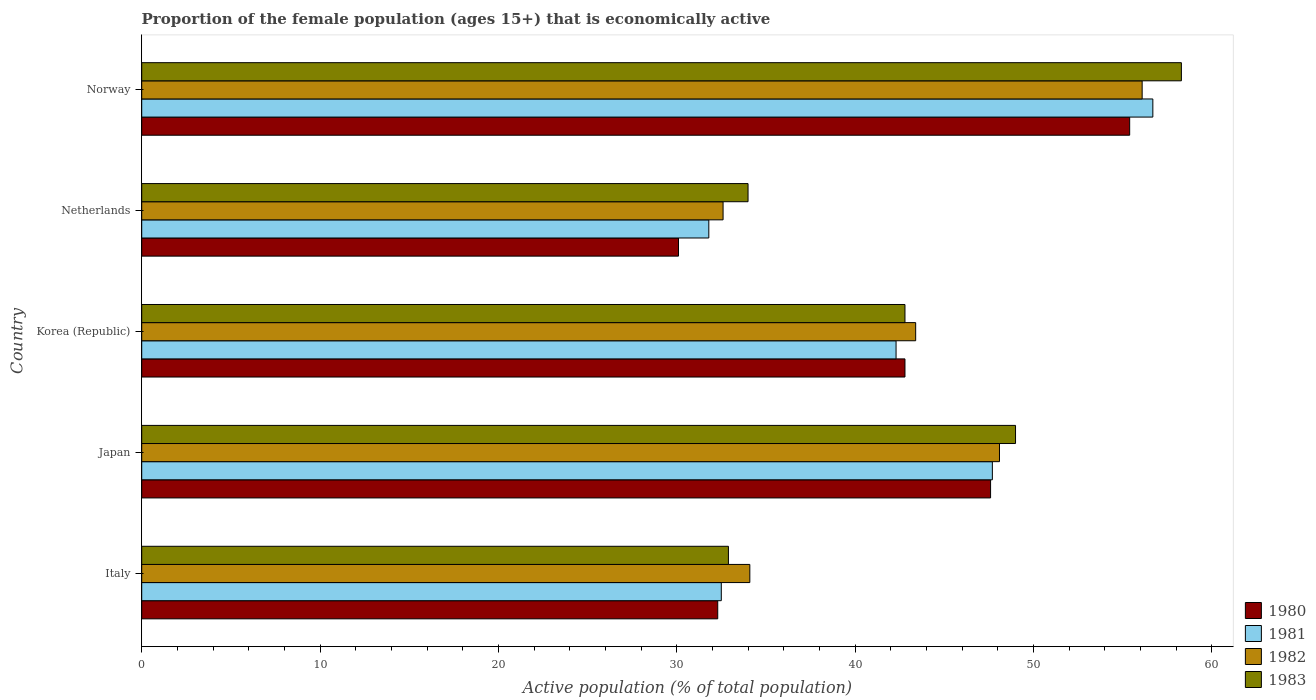How many groups of bars are there?
Offer a terse response. 5. Are the number of bars on each tick of the Y-axis equal?
Offer a terse response. Yes. How many bars are there on the 4th tick from the top?
Provide a short and direct response. 4. How many bars are there on the 5th tick from the bottom?
Your response must be concise. 4. What is the label of the 2nd group of bars from the top?
Give a very brief answer. Netherlands. What is the proportion of the female population that is economically active in 1982 in Norway?
Give a very brief answer. 56.1. Across all countries, what is the maximum proportion of the female population that is economically active in 1982?
Offer a very short reply. 56.1. Across all countries, what is the minimum proportion of the female population that is economically active in 1983?
Keep it short and to the point. 32.9. In which country was the proportion of the female population that is economically active in 1983 maximum?
Offer a very short reply. Norway. What is the total proportion of the female population that is economically active in 1980 in the graph?
Your answer should be compact. 208.2. What is the difference between the proportion of the female population that is economically active in 1983 in Italy and the proportion of the female population that is economically active in 1980 in Norway?
Offer a terse response. -22.5. What is the average proportion of the female population that is economically active in 1982 per country?
Your answer should be very brief. 42.86. What is the difference between the proportion of the female population that is economically active in 1980 and proportion of the female population that is economically active in 1981 in Japan?
Your response must be concise. -0.1. What is the ratio of the proportion of the female population that is economically active in 1983 in Japan to that in Norway?
Provide a short and direct response. 0.84. Is the difference between the proportion of the female population that is economically active in 1980 in Japan and Korea (Republic) greater than the difference between the proportion of the female population that is economically active in 1981 in Japan and Korea (Republic)?
Provide a short and direct response. No. What is the difference between the highest and the lowest proportion of the female population that is economically active in 1980?
Your answer should be very brief. 25.3. In how many countries, is the proportion of the female population that is economically active in 1981 greater than the average proportion of the female population that is economically active in 1981 taken over all countries?
Provide a short and direct response. 3. Is the sum of the proportion of the female population that is economically active in 1983 in Korea (Republic) and Norway greater than the maximum proportion of the female population that is economically active in 1981 across all countries?
Your answer should be very brief. Yes. What does the 1st bar from the bottom in Japan represents?
Ensure brevity in your answer.  1980. Is it the case that in every country, the sum of the proportion of the female population that is economically active in 1983 and proportion of the female population that is economically active in 1980 is greater than the proportion of the female population that is economically active in 1982?
Provide a short and direct response. Yes. Are the values on the major ticks of X-axis written in scientific E-notation?
Offer a very short reply. No. How are the legend labels stacked?
Make the answer very short. Vertical. What is the title of the graph?
Your response must be concise. Proportion of the female population (ages 15+) that is economically active. Does "2006" appear as one of the legend labels in the graph?
Offer a terse response. No. What is the label or title of the X-axis?
Offer a very short reply. Active population (% of total population). What is the label or title of the Y-axis?
Make the answer very short. Country. What is the Active population (% of total population) of 1980 in Italy?
Provide a short and direct response. 32.3. What is the Active population (% of total population) in 1981 in Italy?
Your answer should be very brief. 32.5. What is the Active population (% of total population) of 1982 in Italy?
Your answer should be very brief. 34.1. What is the Active population (% of total population) of 1983 in Italy?
Provide a short and direct response. 32.9. What is the Active population (% of total population) in 1980 in Japan?
Keep it short and to the point. 47.6. What is the Active population (% of total population) in 1981 in Japan?
Your answer should be very brief. 47.7. What is the Active population (% of total population) in 1982 in Japan?
Offer a terse response. 48.1. What is the Active population (% of total population) of 1983 in Japan?
Provide a short and direct response. 49. What is the Active population (% of total population) of 1980 in Korea (Republic)?
Ensure brevity in your answer.  42.8. What is the Active population (% of total population) in 1981 in Korea (Republic)?
Ensure brevity in your answer.  42.3. What is the Active population (% of total population) in 1982 in Korea (Republic)?
Keep it short and to the point. 43.4. What is the Active population (% of total population) in 1983 in Korea (Republic)?
Make the answer very short. 42.8. What is the Active population (% of total population) of 1980 in Netherlands?
Make the answer very short. 30.1. What is the Active population (% of total population) in 1981 in Netherlands?
Keep it short and to the point. 31.8. What is the Active population (% of total population) of 1982 in Netherlands?
Offer a very short reply. 32.6. What is the Active population (% of total population) of 1980 in Norway?
Give a very brief answer. 55.4. What is the Active population (% of total population) in 1981 in Norway?
Your answer should be compact. 56.7. What is the Active population (% of total population) of 1982 in Norway?
Your answer should be compact. 56.1. What is the Active population (% of total population) of 1983 in Norway?
Make the answer very short. 58.3. Across all countries, what is the maximum Active population (% of total population) of 1980?
Offer a very short reply. 55.4. Across all countries, what is the maximum Active population (% of total population) in 1981?
Give a very brief answer. 56.7. Across all countries, what is the maximum Active population (% of total population) in 1982?
Provide a short and direct response. 56.1. Across all countries, what is the maximum Active population (% of total population) in 1983?
Offer a very short reply. 58.3. Across all countries, what is the minimum Active population (% of total population) in 1980?
Keep it short and to the point. 30.1. Across all countries, what is the minimum Active population (% of total population) of 1981?
Keep it short and to the point. 31.8. Across all countries, what is the minimum Active population (% of total population) in 1982?
Make the answer very short. 32.6. Across all countries, what is the minimum Active population (% of total population) of 1983?
Your answer should be very brief. 32.9. What is the total Active population (% of total population) in 1980 in the graph?
Provide a short and direct response. 208.2. What is the total Active population (% of total population) in 1981 in the graph?
Ensure brevity in your answer.  211. What is the total Active population (% of total population) of 1982 in the graph?
Keep it short and to the point. 214.3. What is the total Active population (% of total population) in 1983 in the graph?
Your answer should be compact. 217. What is the difference between the Active population (% of total population) of 1980 in Italy and that in Japan?
Ensure brevity in your answer.  -15.3. What is the difference between the Active population (% of total population) in 1981 in Italy and that in Japan?
Provide a succinct answer. -15.2. What is the difference between the Active population (% of total population) of 1983 in Italy and that in Japan?
Make the answer very short. -16.1. What is the difference between the Active population (% of total population) in 1980 in Italy and that in Korea (Republic)?
Keep it short and to the point. -10.5. What is the difference between the Active population (% of total population) in 1981 in Italy and that in Korea (Republic)?
Offer a terse response. -9.8. What is the difference between the Active population (% of total population) of 1982 in Italy and that in Korea (Republic)?
Your answer should be very brief. -9.3. What is the difference between the Active population (% of total population) in 1983 in Italy and that in Korea (Republic)?
Give a very brief answer. -9.9. What is the difference between the Active population (% of total population) of 1981 in Italy and that in Netherlands?
Offer a very short reply. 0.7. What is the difference between the Active population (% of total population) of 1982 in Italy and that in Netherlands?
Your answer should be very brief. 1.5. What is the difference between the Active population (% of total population) in 1983 in Italy and that in Netherlands?
Give a very brief answer. -1.1. What is the difference between the Active population (% of total population) in 1980 in Italy and that in Norway?
Make the answer very short. -23.1. What is the difference between the Active population (% of total population) of 1981 in Italy and that in Norway?
Offer a very short reply. -24.2. What is the difference between the Active population (% of total population) in 1983 in Italy and that in Norway?
Provide a short and direct response. -25.4. What is the difference between the Active population (% of total population) in 1982 in Japan and that in Korea (Republic)?
Your answer should be very brief. 4.7. What is the difference between the Active population (% of total population) of 1980 in Japan and that in Netherlands?
Ensure brevity in your answer.  17.5. What is the difference between the Active population (% of total population) in 1982 in Japan and that in Netherlands?
Provide a succinct answer. 15.5. What is the difference between the Active population (% of total population) of 1980 in Japan and that in Norway?
Offer a very short reply. -7.8. What is the difference between the Active population (% of total population) of 1981 in Japan and that in Norway?
Make the answer very short. -9. What is the difference between the Active population (% of total population) of 1982 in Japan and that in Norway?
Make the answer very short. -8. What is the difference between the Active population (% of total population) in 1983 in Japan and that in Norway?
Give a very brief answer. -9.3. What is the difference between the Active population (% of total population) in 1982 in Korea (Republic) and that in Netherlands?
Provide a succinct answer. 10.8. What is the difference between the Active population (% of total population) of 1980 in Korea (Republic) and that in Norway?
Provide a short and direct response. -12.6. What is the difference between the Active population (% of total population) in 1981 in Korea (Republic) and that in Norway?
Provide a succinct answer. -14.4. What is the difference between the Active population (% of total population) of 1982 in Korea (Republic) and that in Norway?
Offer a terse response. -12.7. What is the difference between the Active population (% of total population) in 1983 in Korea (Republic) and that in Norway?
Your response must be concise. -15.5. What is the difference between the Active population (% of total population) in 1980 in Netherlands and that in Norway?
Your answer should be compact. -25.3. What is the difference between the Active population (% of total population) of 1981 in Netherlands and that in Norway?
Ensure brevity in your answer.  -24.9. What is the difference between the Active population (% of total population) of 1982 in Netherlands and that in Norway?
Keep it short and to the point. -23.5. What is the difference between the Active population (% of total population) of 1983 in Netherlands and that in Norway?
Your answer should be compact. -24.3. What is the difference between the Active population (% of total population) of 1980 in Italy and the Active population (% of total population) of 1981 in Japan?
Provide a succinct answer. -15.4. What is the difference between the Active population (% of total population) in 1980 in Italy and the Active population (% of total population) in 1982 in Japan?
Keep it short and to the point. -15.8. What is the difference between the Active population (% of total population) of 1980 in Italy and the Active population (% of total population) of 1983 in Japan?
Your response must be concise. -16.7. What is the difference between the Active population (% of total population) in 1981 in Italy and the Active population (% of total population) in 1982 in Japan?
Keep it short and to the point. -15.6. What is the difference between the Active population (% of total population) in 1981 in Italy and the Active population (% of total population) in 1983 in Japan?
Keep it short and to the point. -16.5. What is the difference between the Active population (% of total population) in 1982 in Italy and the Active population (% of total population) in 1983 in Japan?
Keep it short and to the point. -14.9. What is the difference between the Active population (% of total population) of 1980 in Italy and the Active population (% of total population) of 1982 in Netherlands?
Give a very brief answer. -0.3. What is the difference between the Active population (% of total population) of 1980 in Italy and the Active population (% of total population) of 1981 in Norway?
Your answer should be very brief. -24.4. What is the difference between the Active population (% of total population) in 1980 in Italy and the Active population (% of total population) in 1982 in Norway?
Offer a terse response. -23.8. What is the difference between the Active population (% of total population) of 1981 in Italy and the Active population (% of total population) of 1982 in Norway?
Offer a terse response. -23.6. What is the difference between the Active population (% of total population) of 1981 in Italy and the Active population (% of total population) of 1983 in Norway?
Make the answer very short. -25.8. What is the difference between the Active population (% of total population) in 1982 in Italy and the Active population (% of total population) in 1983 in Norway?
Provide a short and direct response. -24.2. What is the difference between the Active population (% of total population) in 1980 in Japan and the Active population (% of total population) in 1981 in Korea (Republic)?
Ensure brevity in your answer.  5.3. What is the difference between the Active population (% of total population) of 1980 in Japan and the Active population (% of total population) of 1982 in Korea (Republic)?
Keep it short and to the point. 4.2. What is the difference between the Active population (% of total population) in 1980 in Japan and the Active population (% of total population) in 1983 in Korea (Republic)?
Provide a short and direct response. 4.8. What is the difference between the Active population (% of total population) in 1981 in Japan and the Active population (% of total population) in 1982 in Korea (Republic)?
Provide a short and direct response. 4.3. What is the difference between the Active population (% of total population) of 1982 in Japan and the Active population (% of total population) of 1983 in Korea (Republic)?
Your response must be concise. 5.3. What is the difference between the Active population (% of total population) in 1981 in Japan and the Active population (% of total population) in 1983 in Netherlands?
Your answer should be compact. 13.7. What is the difference between the Active population (% of total population) in 1980 in Japan and the Active population (% of total population) in 1983 in Norway?
Your response must be concise. -10.7. What is the difference between the Active population (% of total population) in 1981 in Japan and the Active population (% of total population) in 1983 in Norway?
Give a very brief answer. -10.6. What is the difference between the Active population (% of total population) of 1980 in Korea (Republic) and the Active population (% of total population) of 1982 in Netherlands?
Keep it short and to the point. 10.2. What is the difference between the Active population (% of total population) of 1982 in Korea (Republic) and the Active population (% of total population) of 1983 in Netherlands?
Offer a very short reply. 9.4. What is the difference between the Active population (% of total population) of 1980 in Korea (Republic) and the Active population (% of total population) of 1983 in Norway?
Offer a very short reply. -15.5. What is the difference between the Active population (% of total population) in 1981 in Korea (Republic) and the Active population (% of total population) in 1982 in Norway?
Offer a very short reply. -13.8. What is the difference between the Active population (% of total population) of 1981 in Korea (Republic) and the Active population (% of total population) of 1983 in Norway?
Give a very brief answer. -16. What is the difference between the Active population (% of total population) of 1982 in Korea (Republic) and the Active population (% of total population) of 1983 in Norway?
Your answer should be very brief. -14.9. What is the difference between the Active population (% of total population) of 1980 in Netherlands and the Active population (% of total population) of 1981 in Norway?
Provide a short and direct response. -26.6. What is the difference between the Active population (% of total population) of 1980 in Netherlands and the Active population (% of total population) of 1983 in Norway?
Your response must be concise. -28.2. What is the difference between the Active population (% of total population) of 1981 in Netherlands and the Active population (% of total population) of 1982 in Norway?
Offer a terse response. -24.3. What is the difference between the Active population (% of total population) of 1981 in Netherlands and the Active population (% of total population) of 1983 in Norway?
Make the answer very short. -26.5. What is the difference between the Active population (% of total population) in 1982 in Netherlands and the Active population (% of total population) in 1983 in Norway?
Your response must be concise. -25.7. What is the average Active population (% of total population) in 1980 per country?
Provide a succinct answer. 41.64. What is the average Active population (% of total population) in 1981 per country?
Ensure brevity in your answer.  42.2. What is the average Active population (% of total population) of 1982 per country?
Ensure brevity in your answer.  42.86. What is the average Active population (% of total population) of 1983 per country?
Offer a terse response. 43.4. What is the difference between the Active population (% of total population) of 1980 and Active population (% of total population) of 1982 in Italy?
Make the answer very short. -1.8. What is the difference between the Active population (% of total population) in 1981 and Active population (% of total population) in 1982 in Italy?
Provide a short and direct response. -1.6. What is the difference between the Active population (% of total population) in 1982 and Active population (% of total population) in 1983 in Italy?
Your response must be concise. 1.2. What is the difference between the Active population (% of total population) of 1980 and Active population (% of total population) of 1981 in Japan?
Offer a very short reply. -0.1. What is the difference between the Active population (% of total population) of 1980 and Active population (% of total population) of 1982 in Japan?
Offer a terse response. -0.5. What is the difference between the Active population (% of total population) in 1980 and Active population (% of total population) in 1983 in Japan?
Your answer should be very brief. -1.4. What is the difference between the Active population (% of total population) of 1981 and Active population (% of total population) of 1983 in Japan?
Your response must be concise. -1.3. What is the difference between the Active population (% of total population) of 1982 and Active population (% of total population) of 1983 in Japan?
Ensure brevity in your answer.  -0.9. What is the difference between the Active population (% of total population) of 1980 and Active population (% of total population) of 1981 in Korea (Republic)?
Give a very brief answer. 0.5. What is the difference between the Active population (% of total population) of 1980 and Active population (% of total population) of 1982 in Korea (Republic)?
Give a very brief answer. -0.6. What is the difference between the Active population (% of total population) in 1980 and Active population (% of total population) in 1983 in Korea (Republic)?
Provide a short and direct response. 0. What is the difference between the Active population (% of total population) of 1981 and Active population (% of total population) of 1982 in Korea (Republic)?
Offer a terse response. -1.1. What is the difference between the Active population (% of total population) in 1982 and Active population (% of total population) in 1983 in Korea (Republic)?
Offer a terse response. 0.6. What is the difference between the Active population (% of total population) in 1980 and Active population (% of total population) in 1982 in Netherlands?
Provide a succinct answer. -2.5. What is the difference between the Active population (% of total population) in 1980 and Active population (% of total population) in 1983 in Netherlands?
Your answer should be compact. -3.9. What is the difference between the Active population (% of total population) of 1981 and Active population (% of total population) of 1982 in Netherlands?
Your answer should be compact. -0.8. What is the difference between the Active population (% of total population) in 1981 and Active population (% of total population) in 1983 in Netherlands?
Offer a very short reply. -2.2. What is the difference between the Active population (% of total population) of 1980 and Active population (% of total population) of 1981 in Norway?
Your answer should be very brief. -1.3. What is the difference between the Active population (% of total population) of 1980 and Active population (% of total population) of 1982 in Norway?
Your answer should be very brief. -0.7. What is the difference between the Active population (% of total population) in 1980 and Active population (% of total population) in 1983 in Norway?
Offer a terse response. -2.9. What is the difference between the Active population (% of total population) of 1981 and Active population (% of total population) of 1983 in Norway?
Keep it short and to the point. -1.6. What is the ratio of the Active population (% of total population) of 1980 in Italy to that in Japan?
Make the answer very short. 0.68. What is the ratio of the Active population (% of total population) in 1981 in Italy to that in Japan?
Your answer should be very brief. 0.68. What is the ratio of the Active population (% of total population) of 1982 in Italy to that in Japan?
Your answer should be very brief. 0.71. What is the ratio of the Active population (% of total population) in 1983 in Italy to that in Japan?
Give a very brief answer. 0.67. What is the ratio of the Active population (% of total population) in 1980 in Italy to that in Korea (Republic)?
Your answer should be very brief. 0.75. What is the ratio of the Active population (% of total population) in 1981 in Italy to that in Korea (Republic)?
Provide a short and direct response. 0.77. What is the ratio of the Active population (% of total population) in 1982 in Italy to that in Korea (Republic)?
Offer a terse response. 0.79. What is the ratio of the Active population (% of total population) in 1983 in Italy to that in Korea (Republic)?
Provide a succinct answer. 0.77. What is the ratio of the Active population (% of total population) in 1980 in Italy to that in Netherlands?
Give a very brief answer. 1.07. What is the ratio of the Active population (% of total population) of 1982 in Italy to that in Netherlands?
Provide a short and direct response. 1.05. What is the ratio of the Active population (% of total population) of 1983 in Italy to that in Netherlands?
Your answer should be very brief. 0.97. What is the ratio of the Active population (% of total population) of 1980 in Italy to that in Norway?
Ensure brevity in your answer.  0.58. What is the ratio of the Active population (% of total population) of 1981 in Italy to that in Norway?
Offer a very short reply. 0.57. What is the ratio of the Active population (% of total population) in 1982 in Italy to that in Norway?
Offer a very short reply. 0.61. What is the ratio of the Active population (% of total population) of 1983 in Italy to that in Norway?
Your response must be concise. 0.56. What is the ratio of the Active population (% of total population) of 1980 in Japan to that in Korea (Republic)?
Provide a short and direct response. 1.11. What is the ratio of the Active population (% of total population) in 1981 in Japan to that in Korea (Republic)?
Your answer should be compact. 1.13. What is the ratio of the Active population (% of total population) of 1982 in Japan to that in Korea (Republic)?
Provide a succinct answer. 1.11. What is the ratio of the Active population (% of total population) in 1983 in Japan to that in Korea (Republic)?
Provide a succinct answer. 1.14. What is the ratio of the Active population (% of total population) in 1980 in Japan to that in Netherlands?
Ensure brevity in your answer.  1.58. What is the ratio of the Active population (% of total population) of 1982 in Japan to that in Netherlands?
Offer a very short reply. 1.48. What is the ratio of the Active population (% of total population) in 1983 in Japan to that in Netherlands?
Provide a short and direct response. 1.44. What is the ratio of the Active population (% of total population) of 1980 in Japan to that in Norway?
Provide a short and direct response. 0.86. What is the ratio of the Active population (% of total population) in 1981 in Japan to that in Norway?
Provide a short and direct response. 0.84. What is the ratio of the Active population (% of total population) of 1982 in Japan to that in Norway?
Your answer should be compact. 0.86. What is the ratio of the Active population (% of total population) in 1983 in Japan to that in Norway?
Keep it short and to the point. 0.84. What is the ratio of the Active population (% of total population) of 1980 in Korea (Republic) to that in Netherlands?
Provide a succinct answer. 1.42. What is the ratio of the Active population (% of total population) in 1981 in Korea (Republic) to that in Netherlands?
Make the answer very short. 1.33. What is the ratio of the Active population (% of total population) of 1982 in Korea (Republic) to that in Netherlands?
Your answer should be compact. 1.33. What is the ratio of the Active population (% of total population) of 1983 in Korea (Republic) to that in Netherlands?
Ensure brevity in your answer.  1.26. What is the ratio of the Active population (% of total population) of 1980 in Korea (Republic) to that in Norway?
Your answer should be compact. 0.77. What is the ratio of the Active population (% of total population) in 1981 in Korea (Republic) to that in Norway?
Provide a succinct answer. 0.75. What is the ratio of the Active population (% of total population) of 1982 in Korea (Republic) to that in Norway?
Your answer should be compact. 0.77. What is the ratio of the Active population (% of total population) of 1983 in Korea (Republic) to that in Norway?
Provide a succinct answer. 0.73. What is the ratio of the Active population (% of total population) of 1980 in Netherlands to that in Norway?
Provide a succinct answer. 0.54. What is the ratio of the Active population (% of total population) of 1981 in Netherlands to that in Norway?
Your answer should be compact. 0.56. What is the ratio of the Active population (% of total population) of 1982 in Netherlands to that in Norway?
Your answer should be very brief. 0.58. What is the ratio of the Active population (% of total population) of 1983 in Netherlands to that in Norway?
Ensure brevity in your answer.  0.58. What is the difference between the highest and the second highest Active population (% of total population) in 1981?
Provide a short and direct response. 9. What is the difference between the highest and the lowest Active population (% of total population) in 1980?
Offer a very short reply. 25.3. What is the difference between the highest and the lowest Active population (% of total population) in 1981?
Your answer should be compact. 24.9. What is the difference between the highest and the lowest Active population (% of total population) in 1983?
Ensure brevity in your answer.  25.4. 